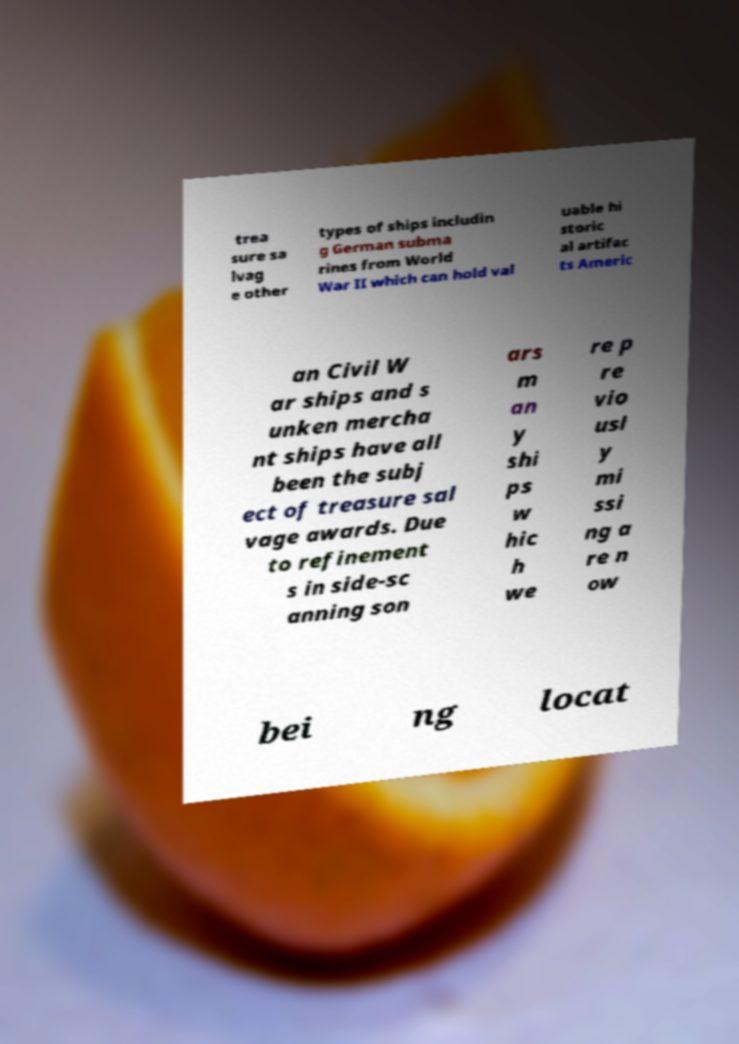Please identify and transcribe the text found in this image. trea sure sa lvag e other types of ships includin g German subma rines from World War II which can hold val uable hi storic al artifac ts Americ an Civil W ar ships and s unken mercha nt ships have all been the subj ect of treasure sal vage awards. Due to refinement s in side-sc anning son ars m an y shi ps w hic h we re p re vio usl y mi ssi ng a re n ow bei ng locat 